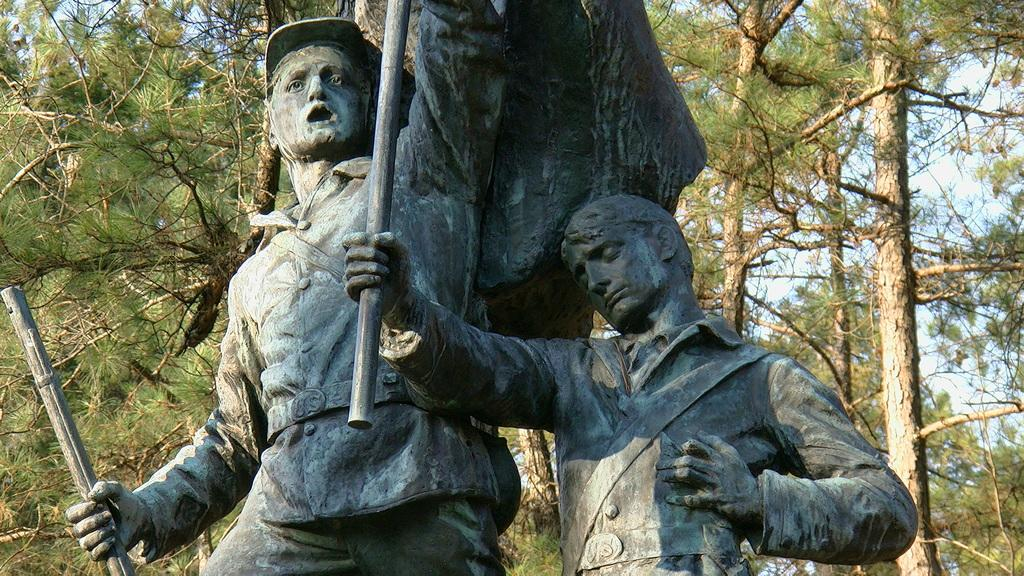What is the main subject in the center of the image? There are statues of persons in the center of the image. What can be seen in the background of the image? There are trees in the background of the image. How many cows are present in the image? There are no cows present in the image; it features statues of persons and trees in the background. 